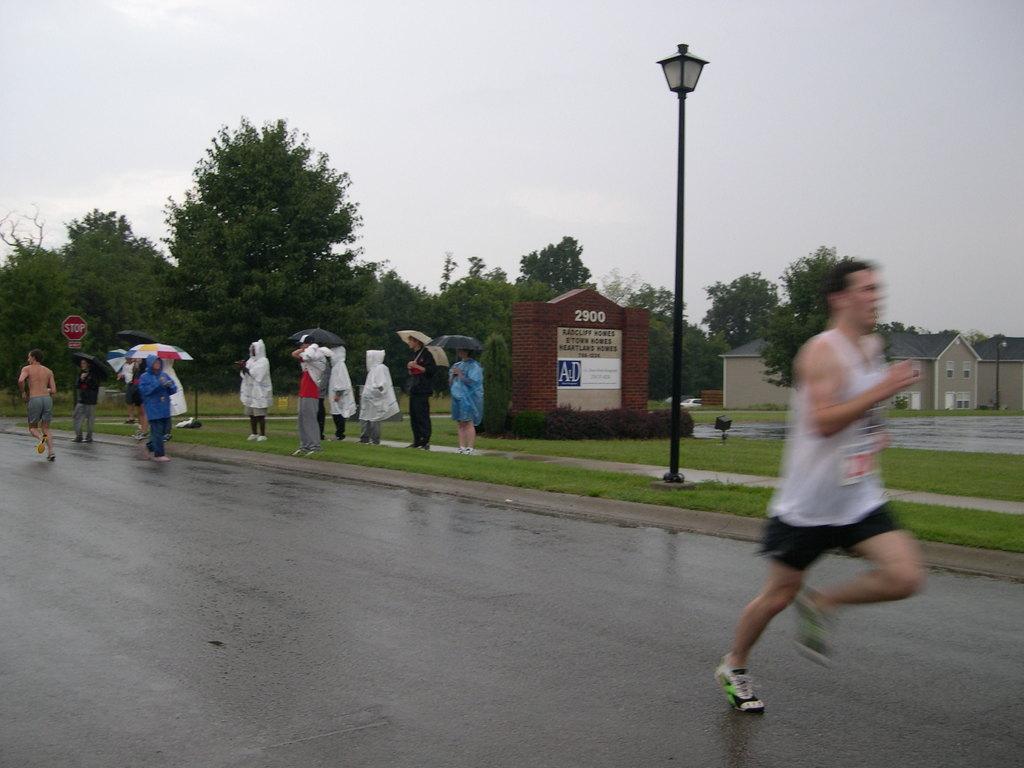Could you give a brief overview of what you see in this image? In this image we can see a man running on the road and there are some people and among them few people are holding umbrellas and we can see a man running on the left side of the image. There is a wall like structure with some text on it and we can see a light pole and there are some houses and trees and at the top we can see the sky. 